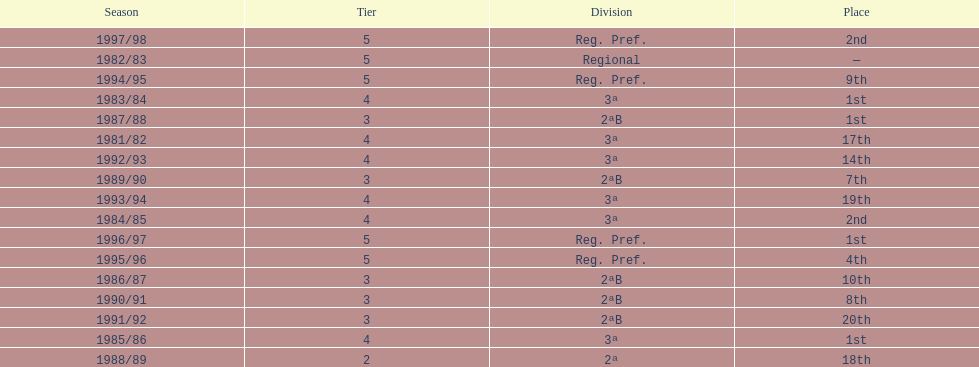What year has no place indicated? 1982/83. 